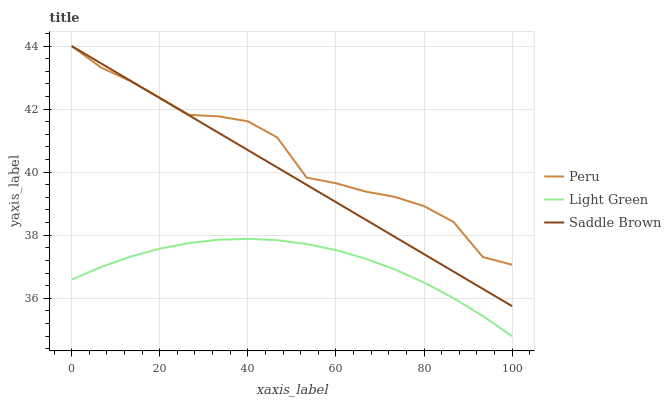Does Light Green have the minimum area under the curve?
Answer yes or no. Yes. Does Peru have the maximum area under the curve?
Answer yes or no. Yes. Does Saddle Brown have the minimum area under the curve?
Answer yes or no. No. Does Saddle Brown have the maximum area under the curve?
Answer yes or no. No. Is Saddle Brown the smoothest?
Answer yes or no. Yes. Is Peru the roughest?
Answer yes or no. Yes. Is Peru the smoothest?
Answer yes or no. No. Is Saddle Brown the roughest?
Answer yes or no. No. Does Light Green have the lowest value?
Answer yes or no. Yes. Does Saddle Brown have the lowest value?
Answer yes or no. No. Does Saddle Brown have the highest value?
Answer yes or no. Yes. Is Light Green less than Peru?
Answer yes or no. Yes. Is Peru greater than Light Green?
Answer yes or no. Yes. Does Peru intersect Saddle Brown?
Answer yes or no. Yes. Is Peru less than Saddle Brown?
Answer yes or no. No. Is Peru greater than Saddle Brown?
Answer yes or no. No. Does Light Green intersect Peru?
Answer yes or no. No. 